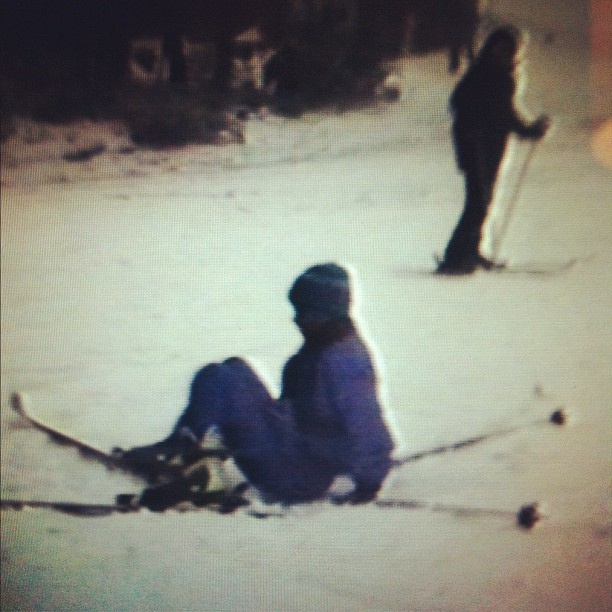Describe the objects in this image and their specific colors. I can see people in black, navy, purple, and darkblue tones, people in black, gray, and darkgray tones, skis in black, gray, and darkgray tones, and skis in black, darkgray, gray, and lightgray tones in this image. 